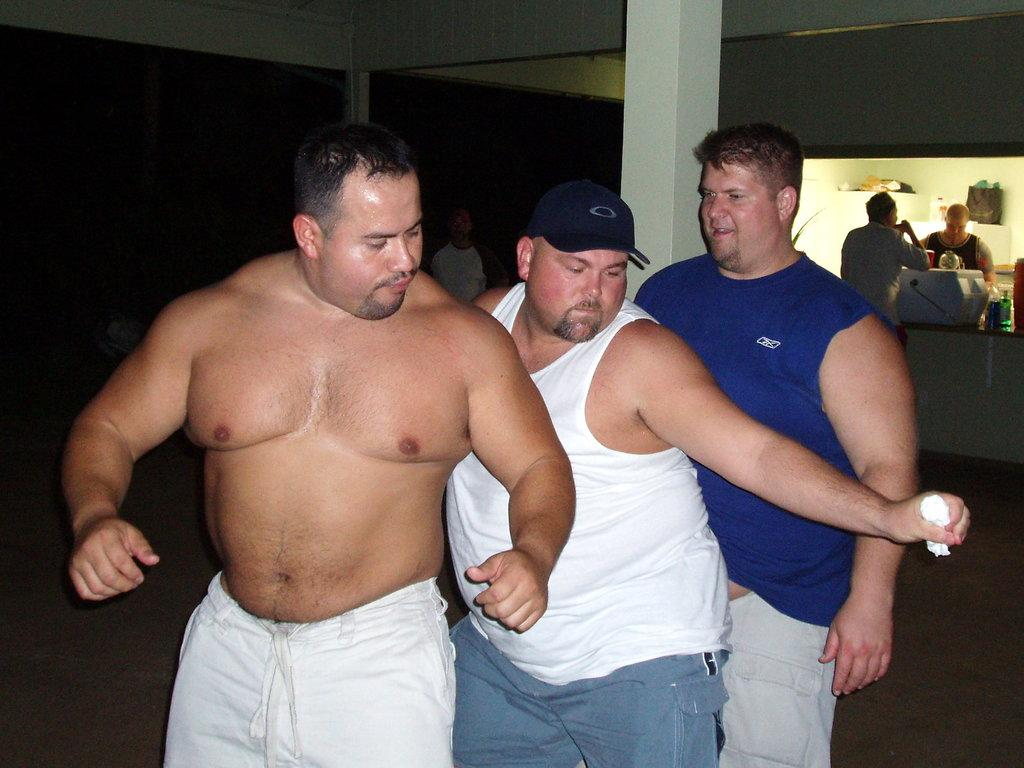How many men are present in the image? There are three men standing in the image. What is located behind the men? There is a pillar behind the men. Can you describe the background of the image? There are people visible in the background of the image. What is at the bottom of the image? There is a floor at the bottom of the image. What type of nut is being used as a desk in the image? There is no nut or desk present in the image. How many shades of color can be seen on the men's clothing in the image? The provided facts do not mention the colors of the men's clothing, so it is impossible to determine the number of shades. 